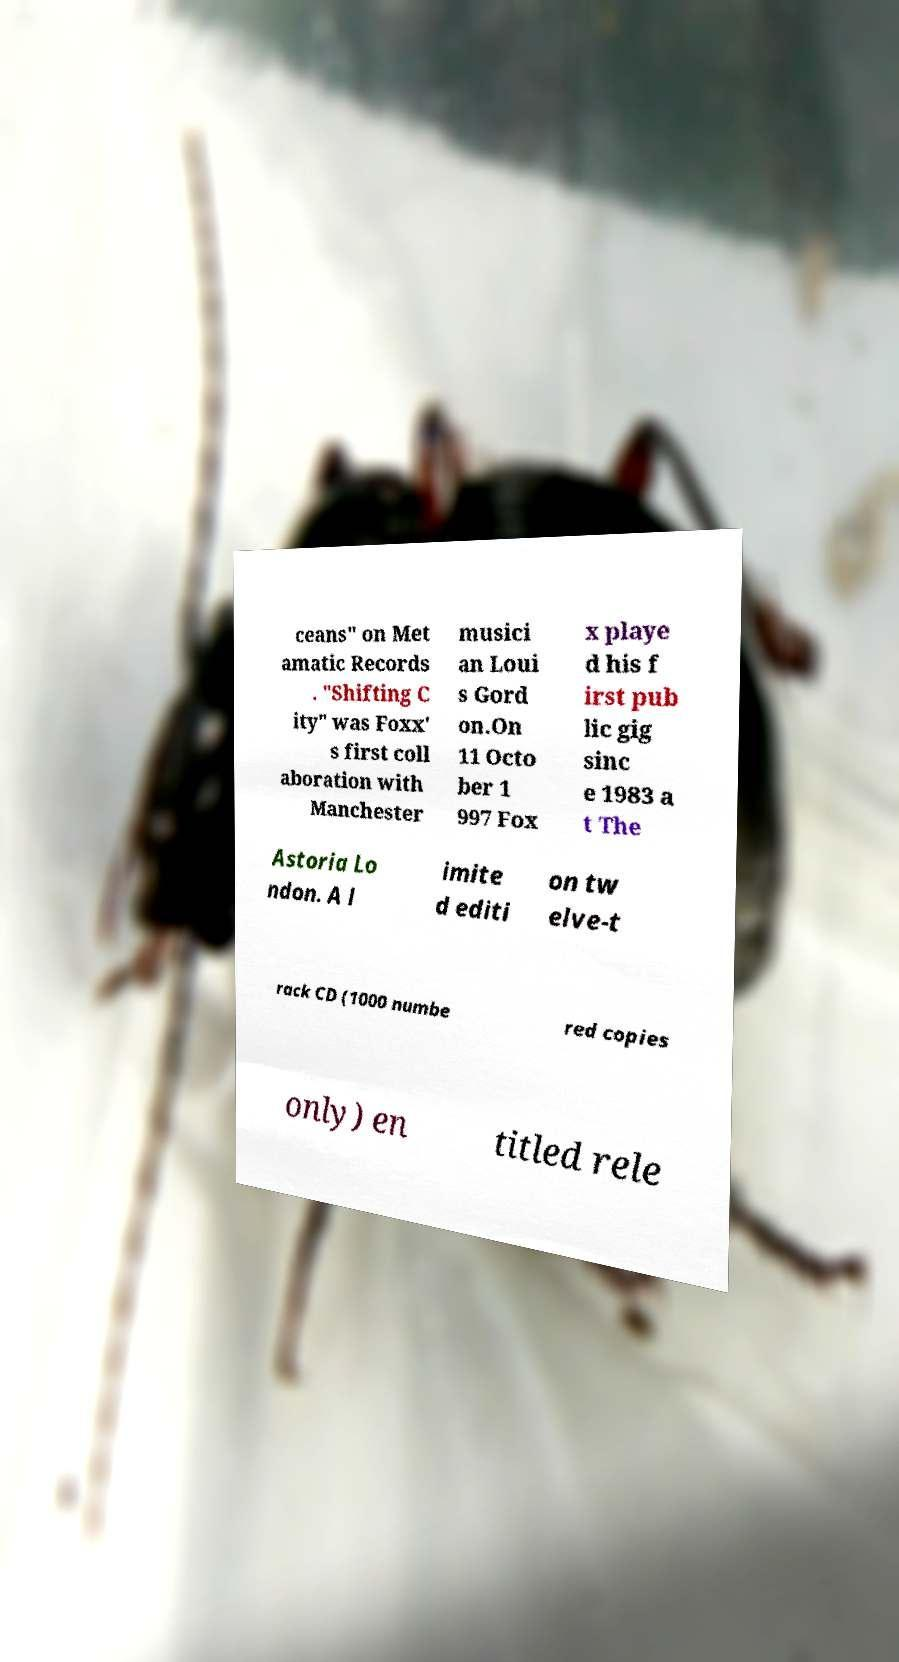What messages or text are displayed in this image? I need them in a readable, typed format. ceans" on Met amatic Records . "Shifting C ity" was Foxx' s first coll aboration with Manchester musici an Loui s Gord on.On 11 Octo ber 1 997 Fox x playe d his f irst pub lic gig sinc e 1983 a t The Astoria Lo ndon. A l imite d editi on tw elve-t rack CD (1000 numbe red copies only) en titled rele 